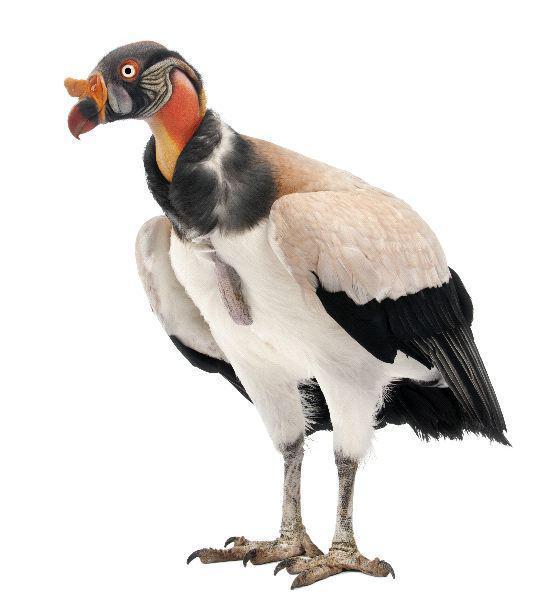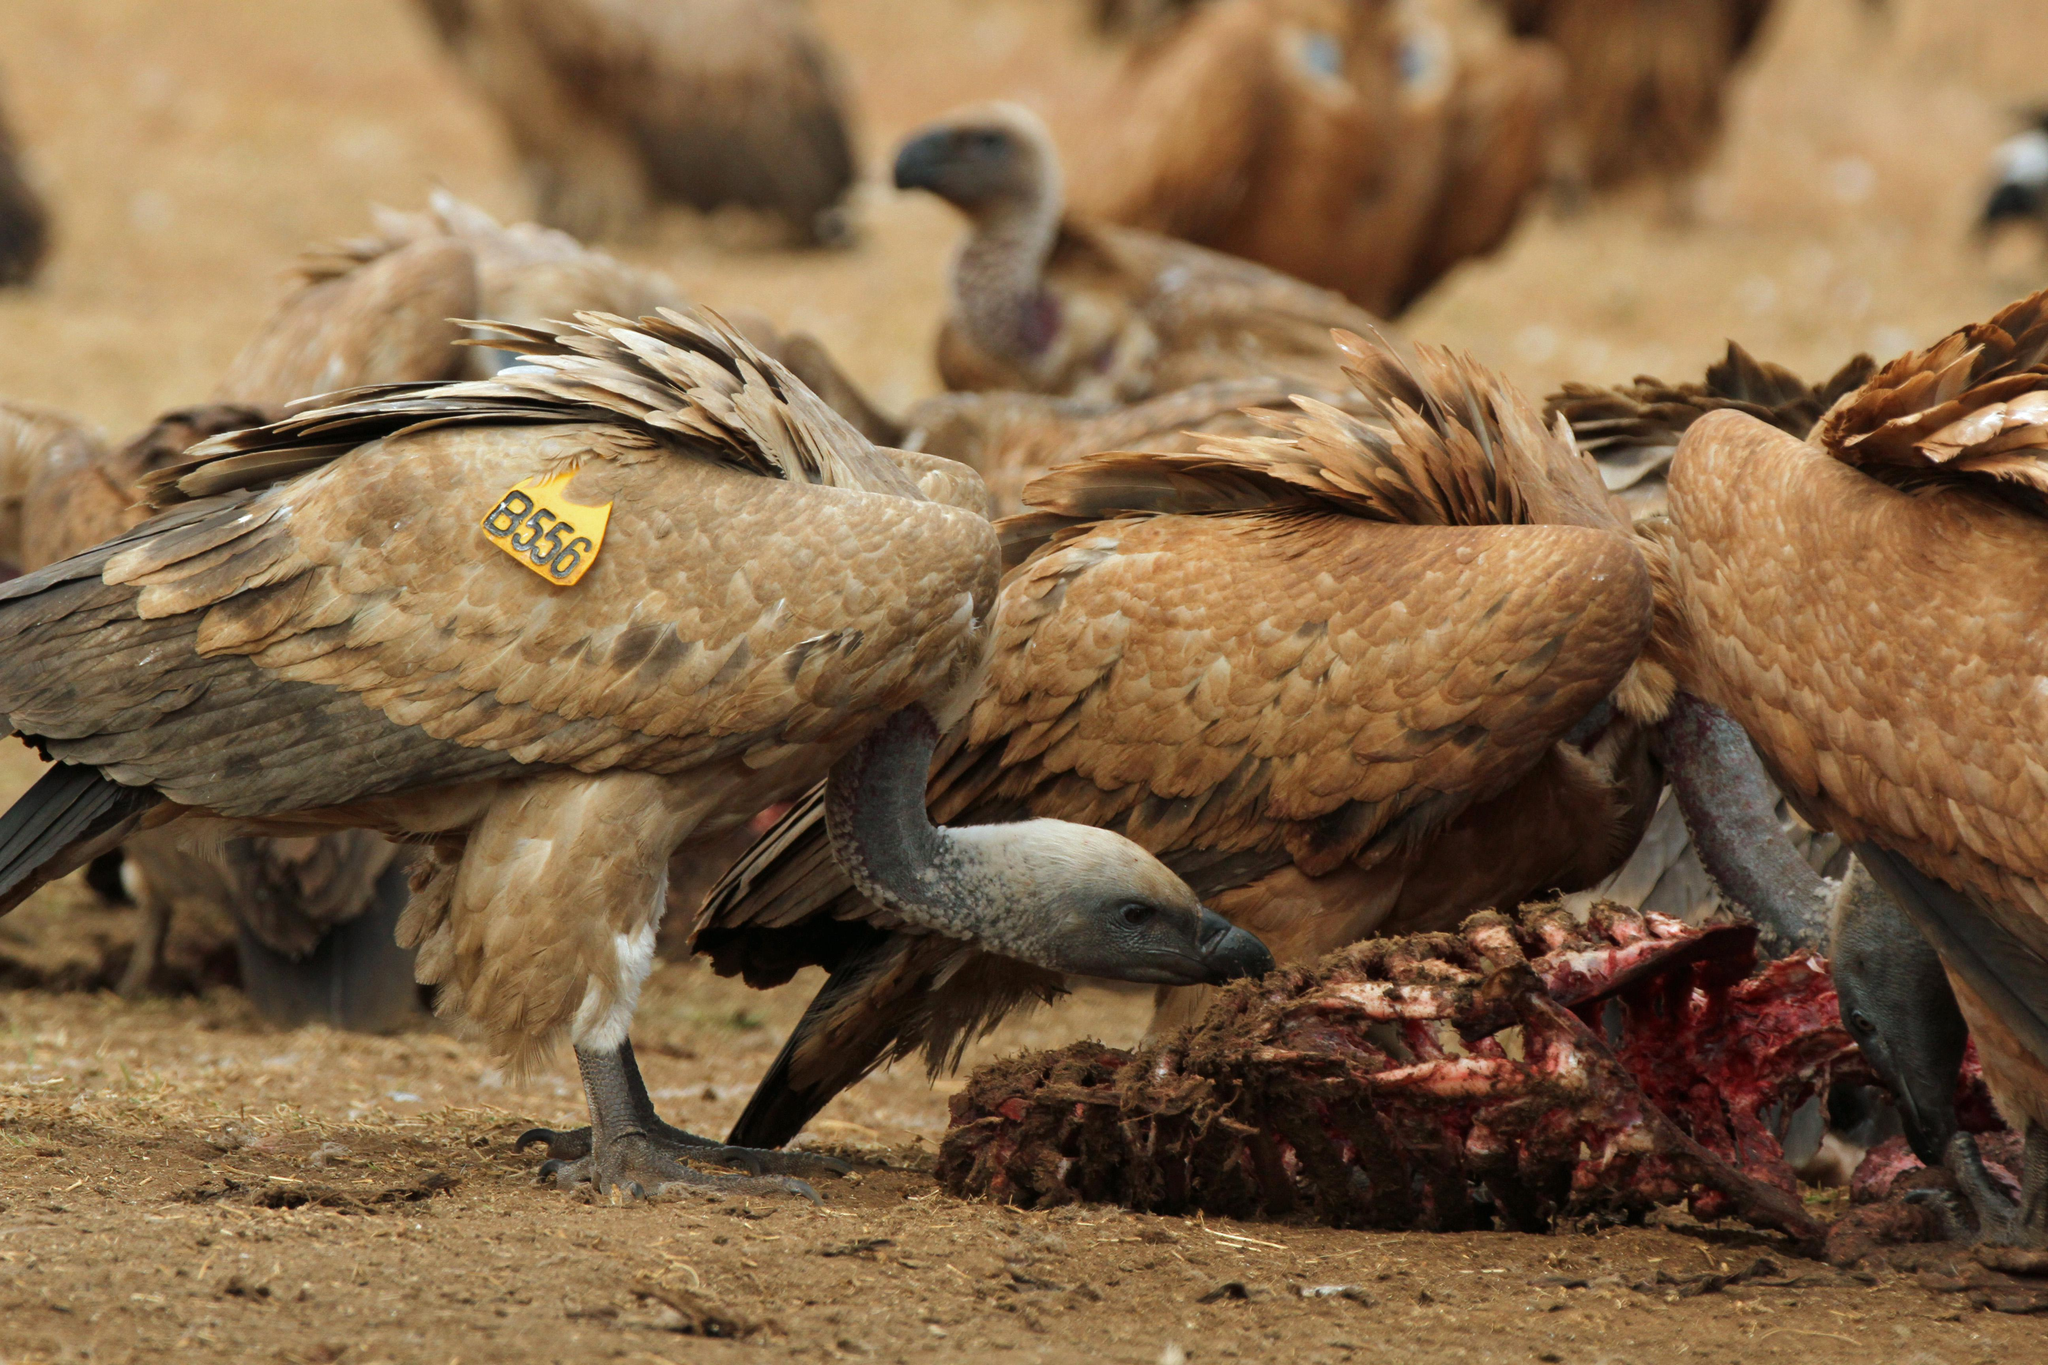The first image is the image on the left, the second image is the image on the right. Assess this claim about the two images: "Both turkey vultures are standing on a tree branch". Correct or not? Answer yes or no. No. The first image is the image on the left, the second image is the image on the right. Evaluate the accuracy of this statement regarding the images: "There is one large bird with black and white feathers that has its wings spread.". Is it true? Answer yes or no. No. 